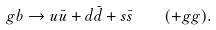Convert formula to latex. <formula><loc_0><loc_0><loc_500><loc_500>g b \to u \bar { u } + d \bar { d } + s \bar { s } \quad ( + g g ) .</formula> 